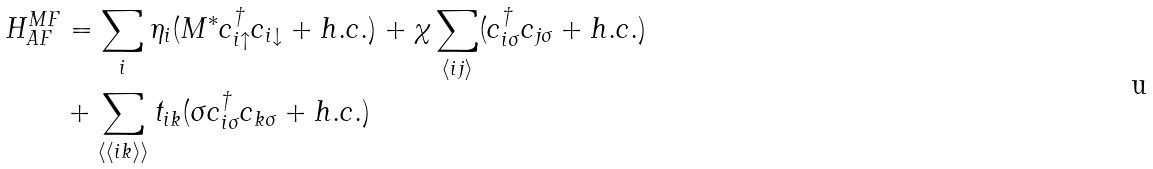<formula> <loc_0><loc_0><loc_500><loc_500>H _ { A F } ^ { M F } & = \sum _ { i } \eta _ { i } ( M ^ { * } c _ { i \uparrow } ^ { \dagger } c _ { i \downarrow } + h . c . ) + \chi \sum _ { \langle i j \rangle } ( c _ { i \sigma } ^ { \dagger } c _ { j \sigma } + h . c . ) \\ & + \sum _ { \langle \langle i k \rangle \rangle } t _ { i k } ( \sigma c _ { i \sigma } ^ { \dagger } c _ { k \sigma } + h . c . )</formula> 